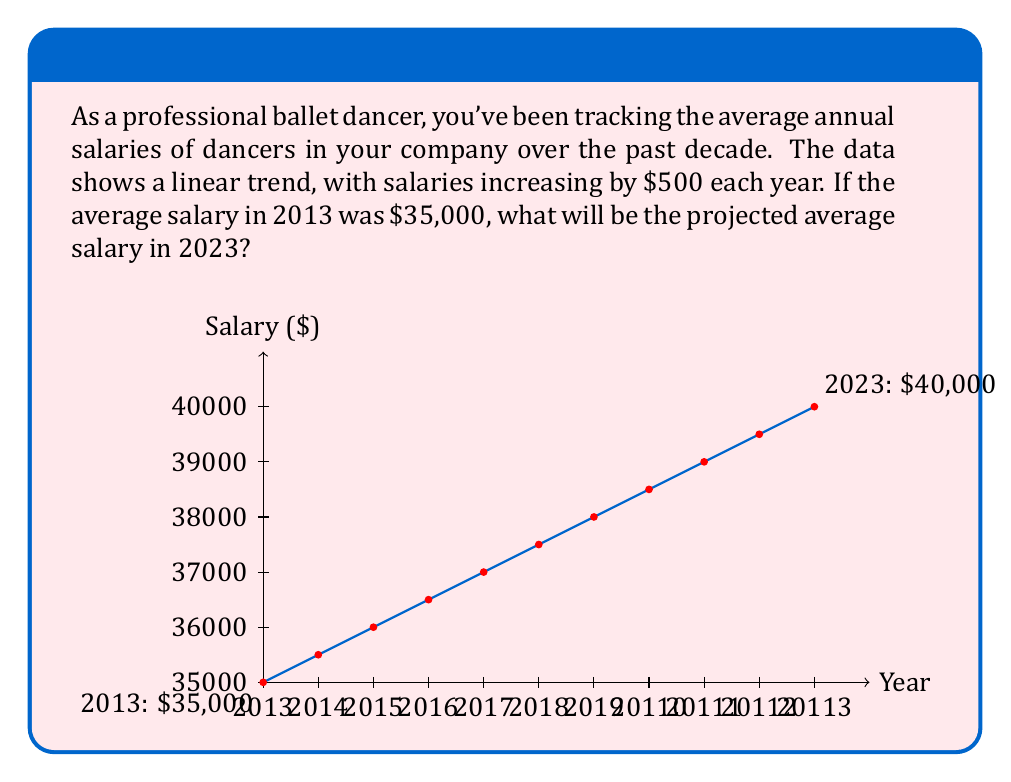Teach me how to tackle this problem. To solve this problem, we'll use the concept of arithmetic sequences in time series analysis. Here's a step-by-step approach:

1) Identify the given information:
   - Starting year: 2013
   - Ending year: 2023
   - Starting salary: $35,000
   - Annual increase: $500

2) Calculate the number of years between 2013 and 2023:
   $$n = 2023 - 2013 = 10 \text{ years}$$

3) Use the arithmetic sequence formula:
   $$a_n = a_1 + (n-1)d$$
   Where:
   $a_n$ is the nth term (2023 salary)
   $a_1$ is the first term ($35,000)
   $n$ is the number of terms (11, as we include both 2013 and 2023)
   $d$ is the common difference ($500)

4) Plug in the values:
   $$a_{11} = 35000 + (11-1) \times 500$$

5) Solve:
   $$a_{11} = 35000 + 10 \times 500 = 35000 + 5000 = 40000$$

Therefore, the projected average salary in 2023 will be $40,000.
Answer: $40,000 